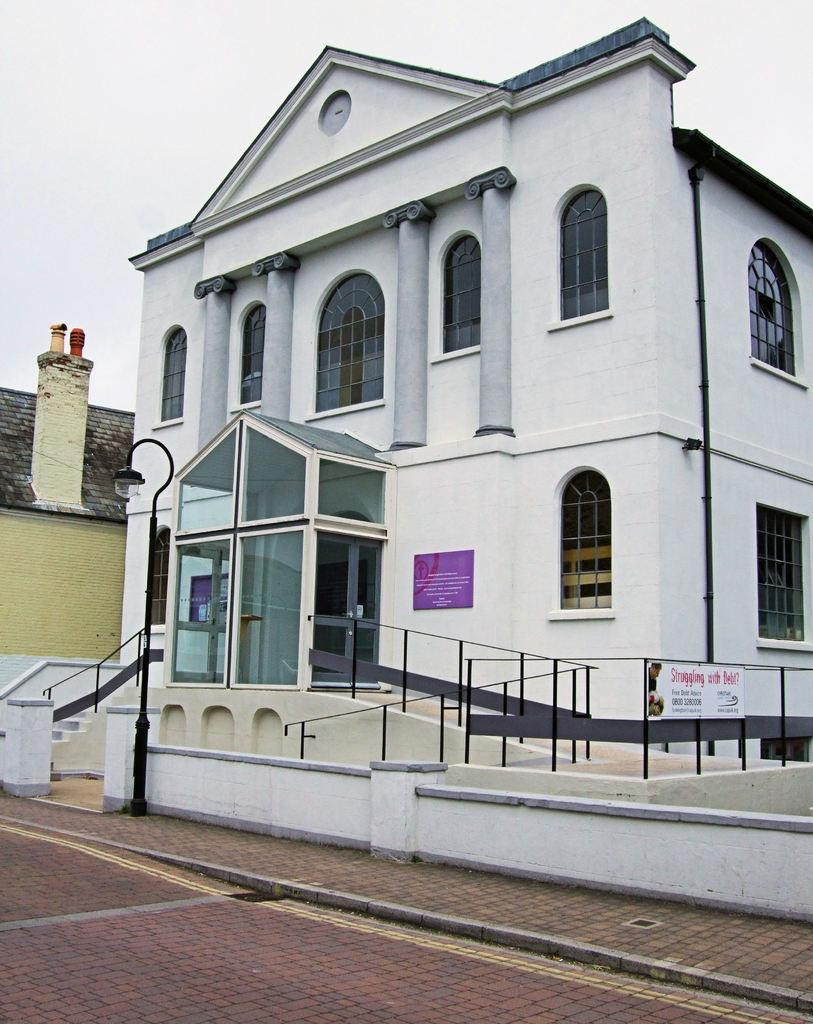What type of structures can be seen in the image? There are buildings in the image. What architectural features are visible on the buildings? There are windows, pillars, and boards visible on the buildings. What is the purpose of the fence in the image? The fence is likely used to define boundaries or provide security. What can be seen at the bottom of the image? There are steps in the image. What is visible in the background of the image? The sky is visible in the image. Can you determine the time of day the image was taken? The image is likely taken during the day, as the sky is visible and there is sufficient light. What is the price of the bottle seen in the image? There is no bottle present in the image. Is there a river flowing through the buildings in the image? There is no river visible in the image. 